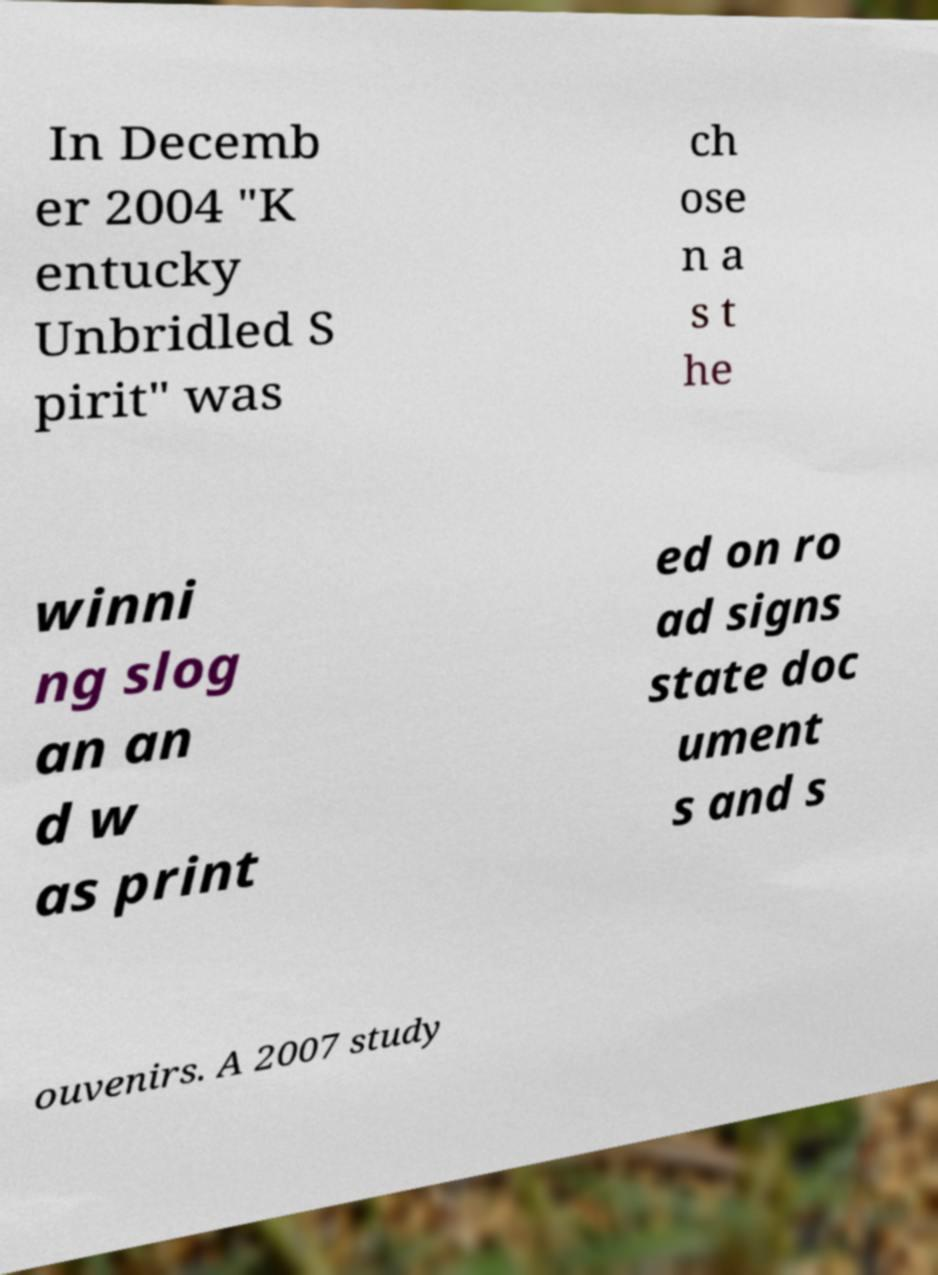There's text embedded in this image that I need extracted. Can you transcribe it verbatim? In Decemb er 2004 "K entucky Unbridled S pirit" was ch ose n a s t he winni ng slog an an d w as print ed on ro ad signs state doc ument s and s ouvenirs. A 2007 study 